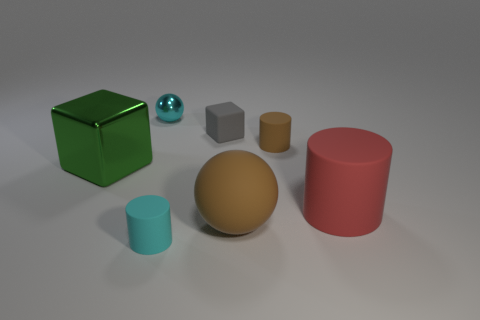Subtract 1 cylinders. How many cylinders are left? 2 Subtract all small rubber cylinders. How many cylinders are left? 1 Add 2 cubes. How many objects exist? 9 Subtract all cubes. How many objects are left? 5 Add 7 brown matte balls. How many brown matte balls exist? 8 Subtract 0 gray balls. How many objects are left? 7 Subtract all metal spheres. Subtract all brown rubber objects. How many objects are left? 4 Add 2 green shiny things. How many green shiny things are left? 3 